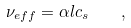<formula> <loc_0><loc_0><loc_500><loc_500>\nu _ { e f f } = \alpha l c _ { s } \quad ,</formula> 